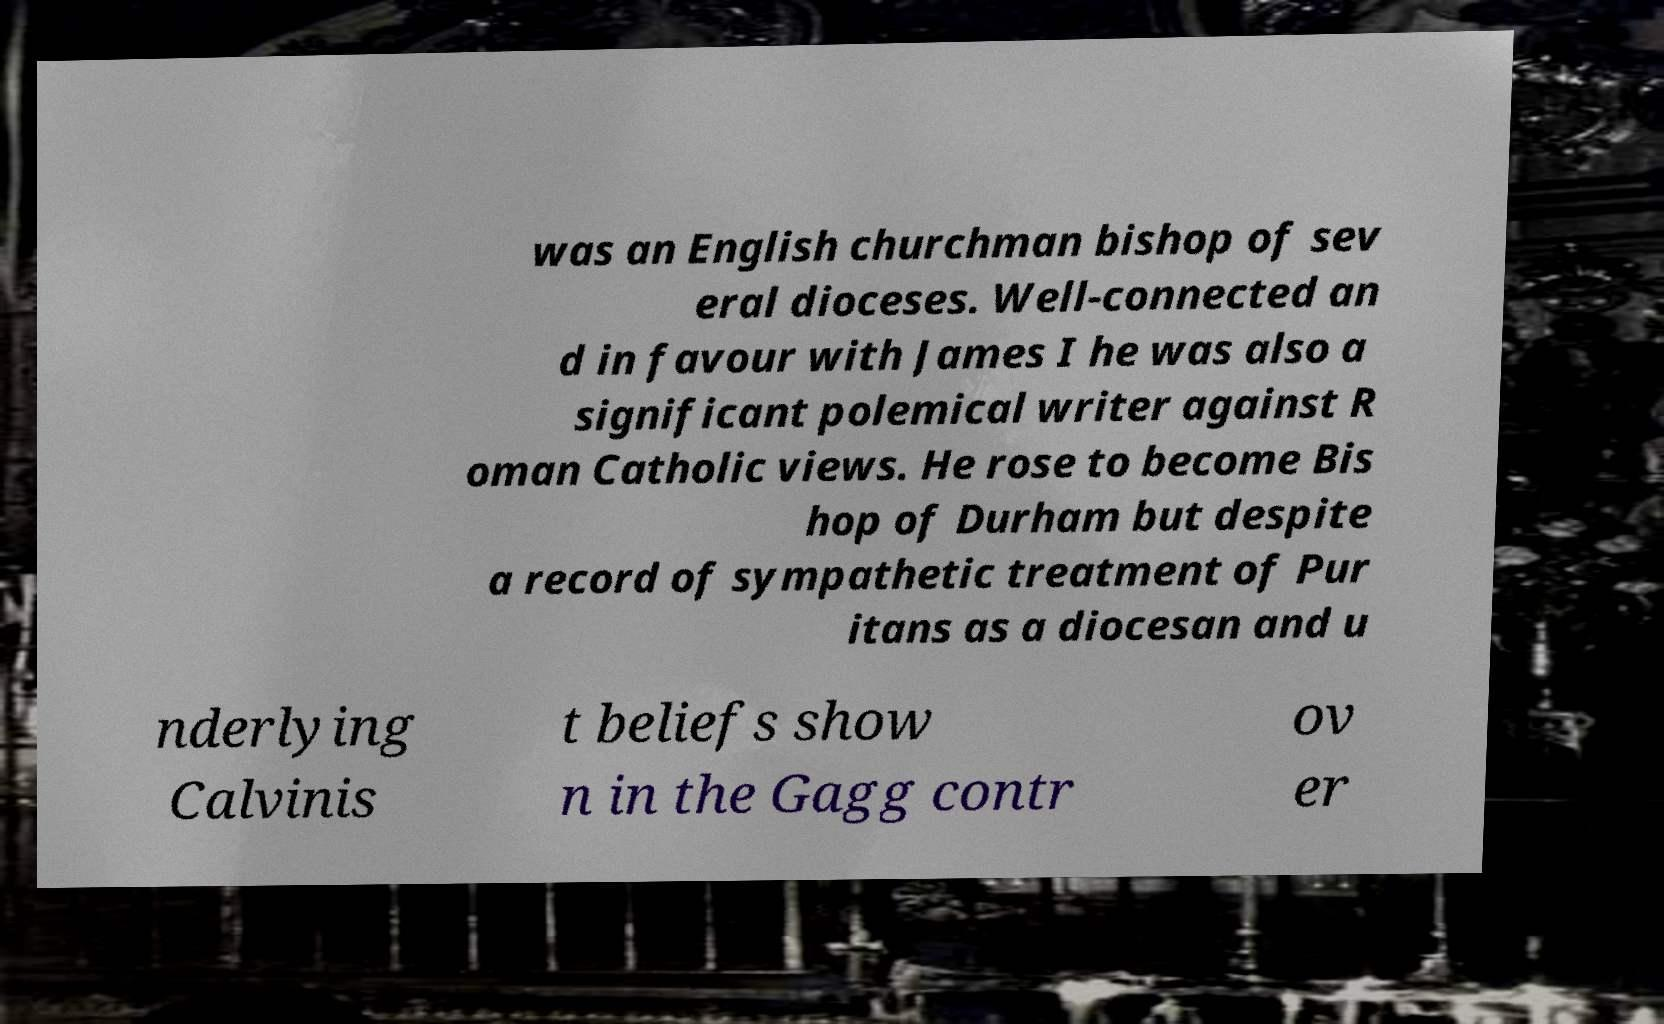For documentation purposes, I need the text within this image transcribed. Could you provide that? was an English churchman bishop of sev eral dioceses. Well-connected an d in favour with James I he was also a significant polemical writer against R oman Catholic views. He rose to become Bis hop of Durham but despite a record of sympathetic treatment of Pur itans as a diocesan and u nderlying Calvinis t beliefs show n in the Gagg contr ov er 